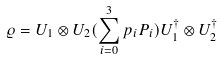Convert formula to latex. <formula><loc_0><loc_0><loc_500><loc_500>\varrho = U _ { 1 } \otimes U _ { 2 } ( \sum _ { i = 0 } ^ { 3 } p _ { i } P _ { i } ) U _ { 1 } ^ { \dagger } \otimes U _ { 2 } ^ { \dagger }</formula> 